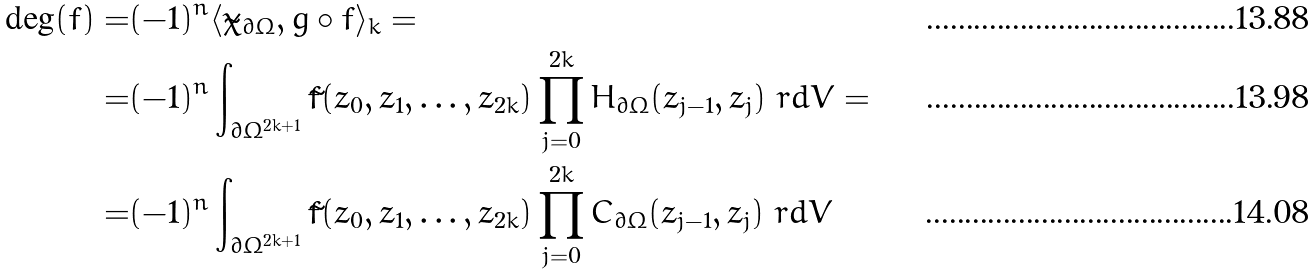<formula> <loc_0><loc_0><loc_500><loc_500>\deg ( f ) = & ( - 1 ) ^ { n } \langle \tilde { \chi } _ { \partial \Omega } , g \circ f \rangle _ { k } = \\ = & ( - 1 ) ^ { n } \int _ { \partial \Omega ^ { 2 k + 1 } } \tilde { f } ( z _ { 0 } , z _ { 1 } , \dots , z _ { 2 k } ) \prod _ { j = 0 } ^ { 2 k } H _ { \partial \Omega } ( z _ { j - 1 } , z _ { j } ) \ r d V = \\ = & ( - 1 ) ^ { n } \int _ { \partial \Omega ^ { 2 k + 1 } } \tilde { f } ( z _ { 0 } , z _ { 1 } , \dots , z _ { 2 k } ) \prod _ { j = 0 } ^ { 2 k } C _ { \partial \Omega } ( z _ { j - 1 } , z _ { j } ) \ r d V</formula> 